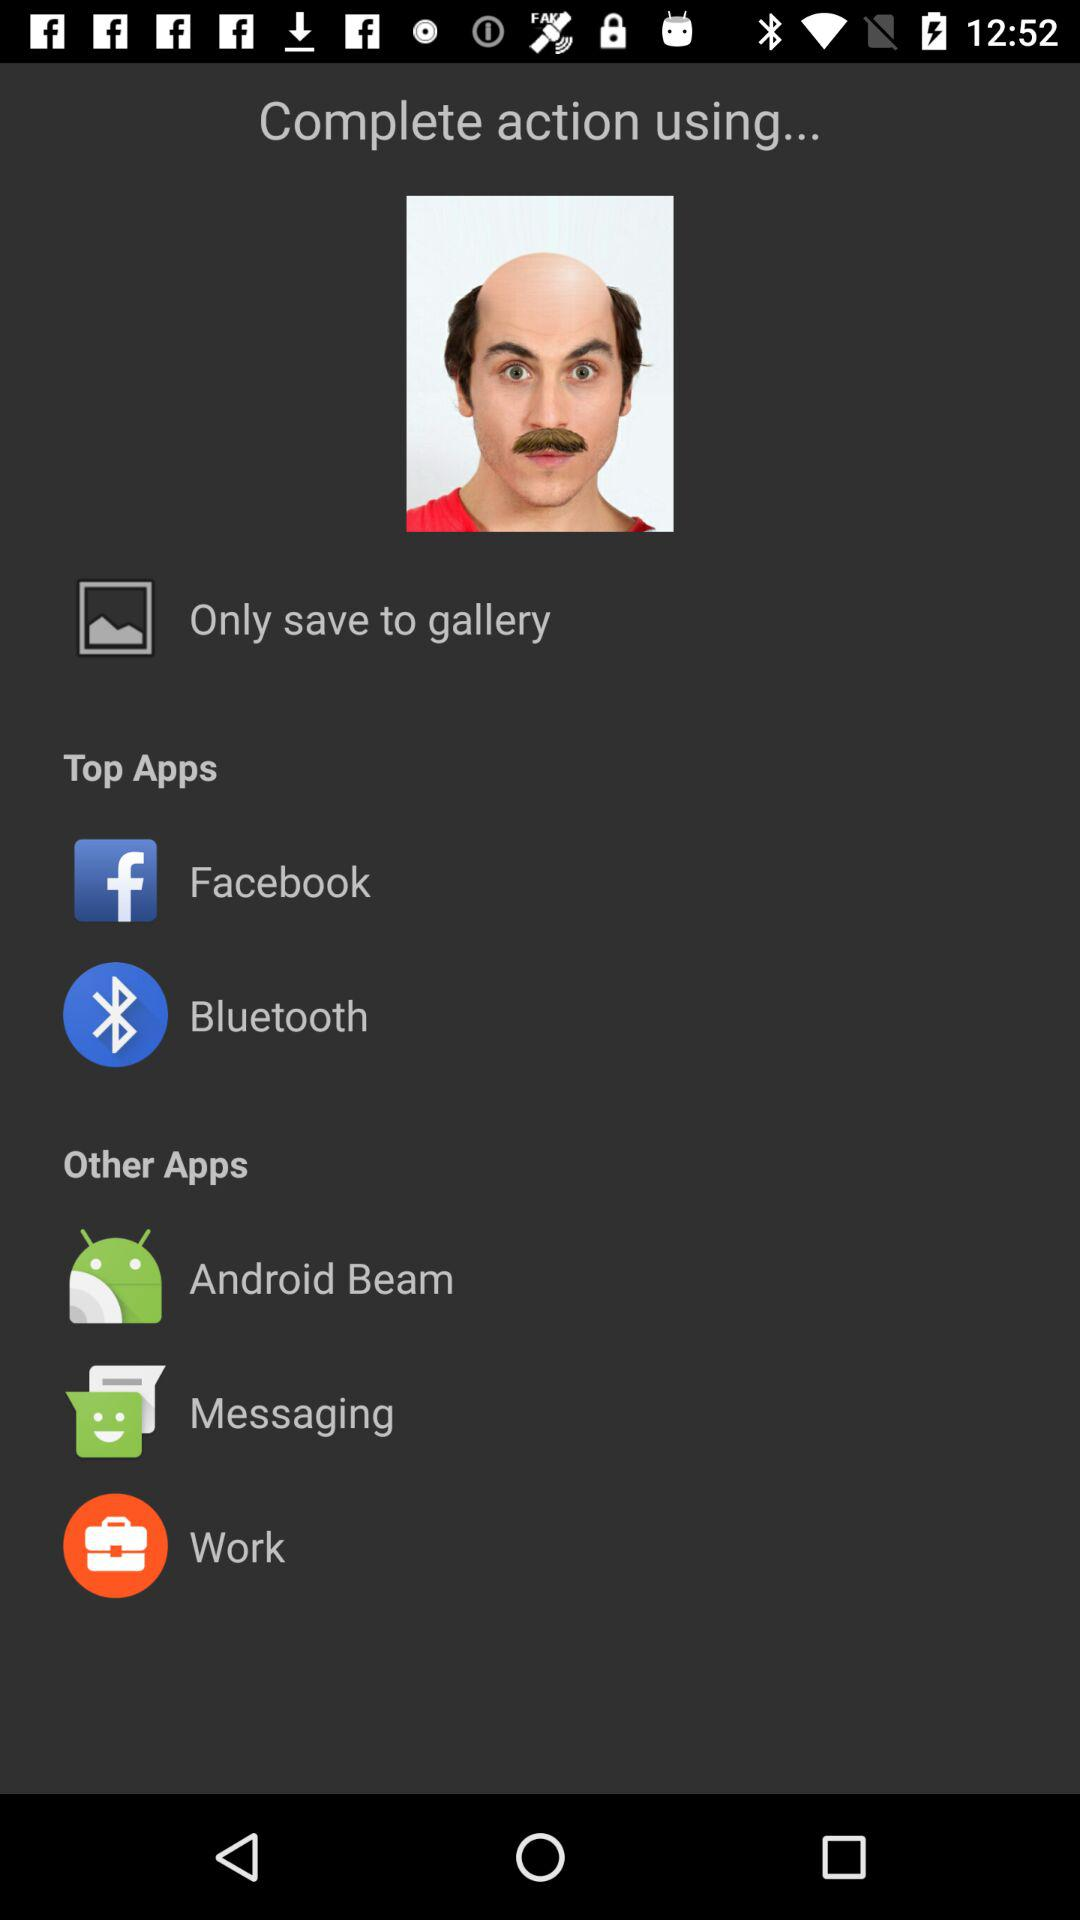Through which applications can the action be completed? The applications are "Facebook", "Bluetooth", "Android Beam", "Messaging" and "Work". 